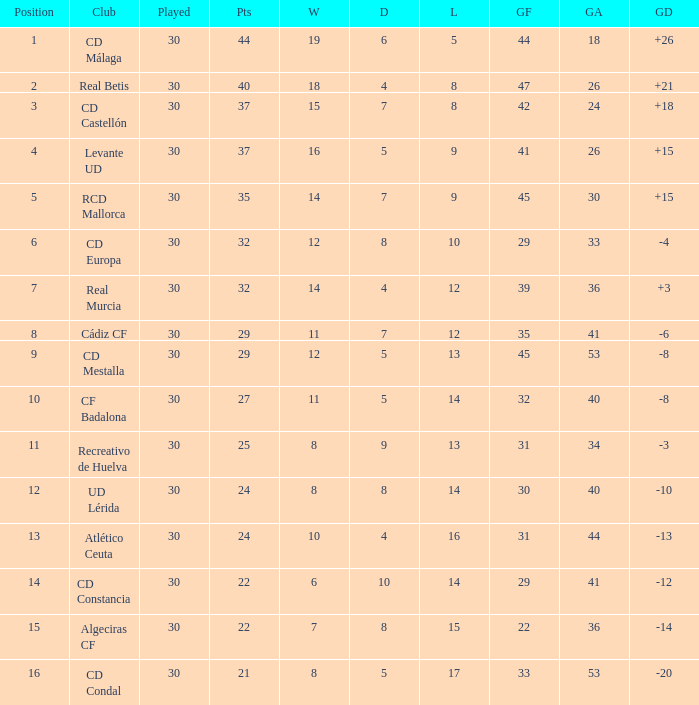What is the goals for when played is larger than 30? None. 